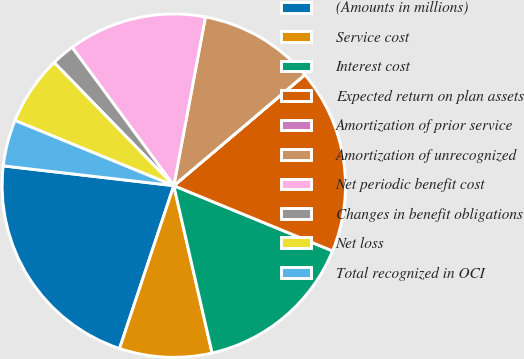Convert chart. <chart><loc_0><loc_0><loc_500><loc_500><pie_chart><fcel>(Amounts in millions)<fcel>Service cost<fcel>Interest cost<fcel>Expected return on plan assets<fcel>Amortization of prior service<fcel>Amortization of unrecognized<fcel>Net periodic benefit cost<fcel>Changes in benefit obligations<fcel>Net loss<fcel>Total recognized in OCI<nl><fcel>21.72%<fcel>8.7%<fcel>15.21%<fcel>17.38%<fcel>0.01%<fcel>10.87%<fcel>13.04%<fcel>2.18%<fcel>6.53%<fcel>4.36%<nl></chart> 